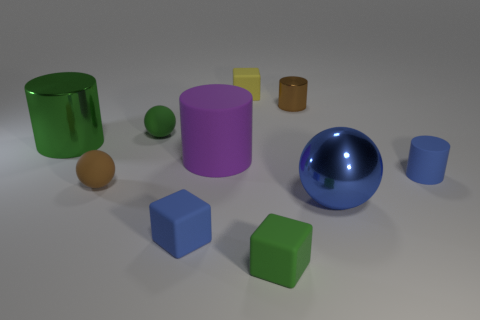Subtract all cyan spheres. Subtract all brown cylinders. How many spheres are left? 3 Subtract all cubes. How many objects are left? 7 Subtract 1 brown cylinders. How many objects are left? 9 Subtract all blue cylinders. Subtract all small green matte objects. How many objects are left? 7 Add 6 yellow objects. How many yellow objects are left? 7 Add 2 large blue rubber things. How many large blue rubber things exist? 2 